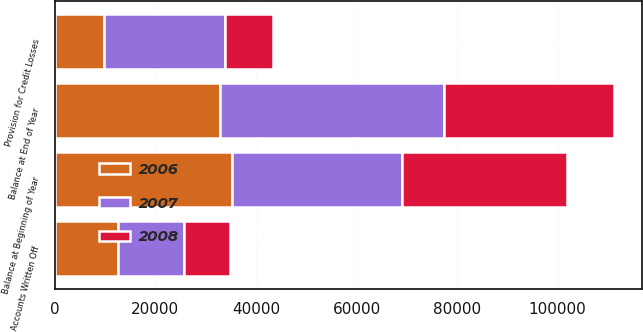Convert chart. <chart><loc_0><loc_0><loc_500><loc_500><stacked_bar_chart><ecel><fcel>Balance at Beginning of Year<fcel>Provision for Credit Losses<fcel>Accounts Written Off<fcel>Balance at End of Year<nl><fcel>2007<fcel>33810<fcel>24037<fcel>13197<fcel>44650<nl><fcel>2008<fcel>32817<fcel>9672<fcel>9174<fcel>33810<nl><fcel>2006<fcel>35239<fcel>9730<fcel>12473<fcel>32817<nl></chart> 